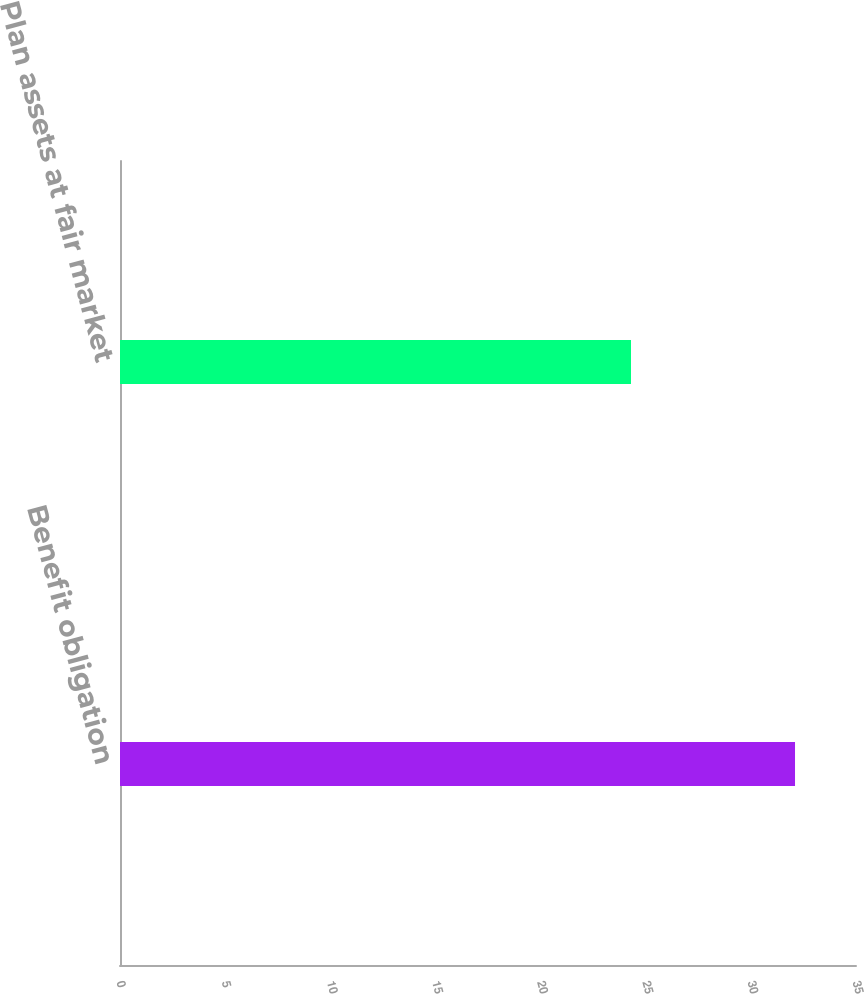<chart> <loc_0><loc_0><loc_500><loc_500><bar_chart><fcel>Benefit obligation<fcel>Plan assets at fair market<nl><fcel>32.1<fcel>24.3<nl></chart> 